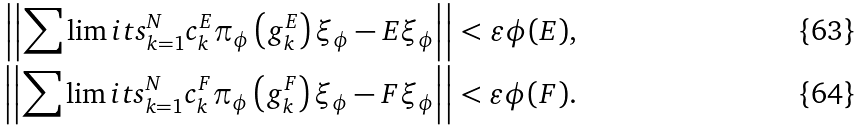Convert formula to latex. <formula><loc_0><loc_0><loc_500><loc_500>\left | \left | \sum \lim i t s _ { k = 1 } ^ { N } c _ { k } ^ { E } \pi _ { \phi } \left ( g _ { k } ^ { E } \right ) \xi _ { \phi } - E \xi _ { \phi } \right | \right | < \varepsilon \phi ( E ) , \\ \left | \left | \sum \lim i t s _ { k = 1 } ^ { N } c _ { k } ^ { F } \pi _ { \phi } \left ( g _ { k } ^ { F } \right ) \xi _ { \phi } - F \xi _ { \phi } \right | \right | < \varepsilon \phi ( F ) .</formula> 